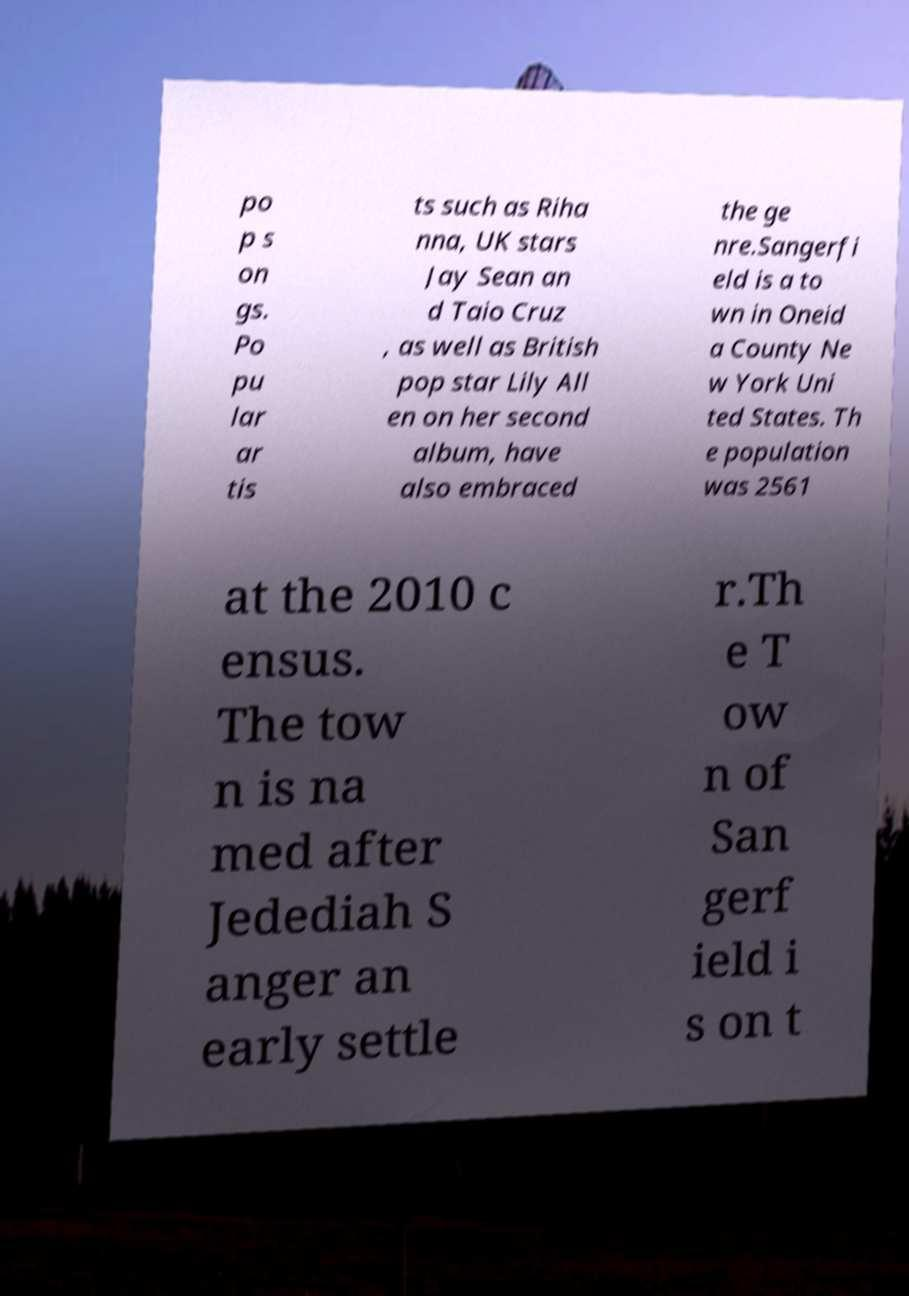Please read and relay the text visible in this image. What does it say? po p s on gs. Po pu lar ar tis ts such as Riha nna, UK stars Jay Sean an d Taio Cruz , as well as British pop star Lily All en on her second album, have also embraced the ge nre.Sangerfi eld is a to wn in Oneid a County Ne w York Uni ted States. Th e population was 2561 at the 2010 c ensus. The tow n is na med after Jedediah S anger an early settle r.Th e T ow n of San gerf ield i s on t 